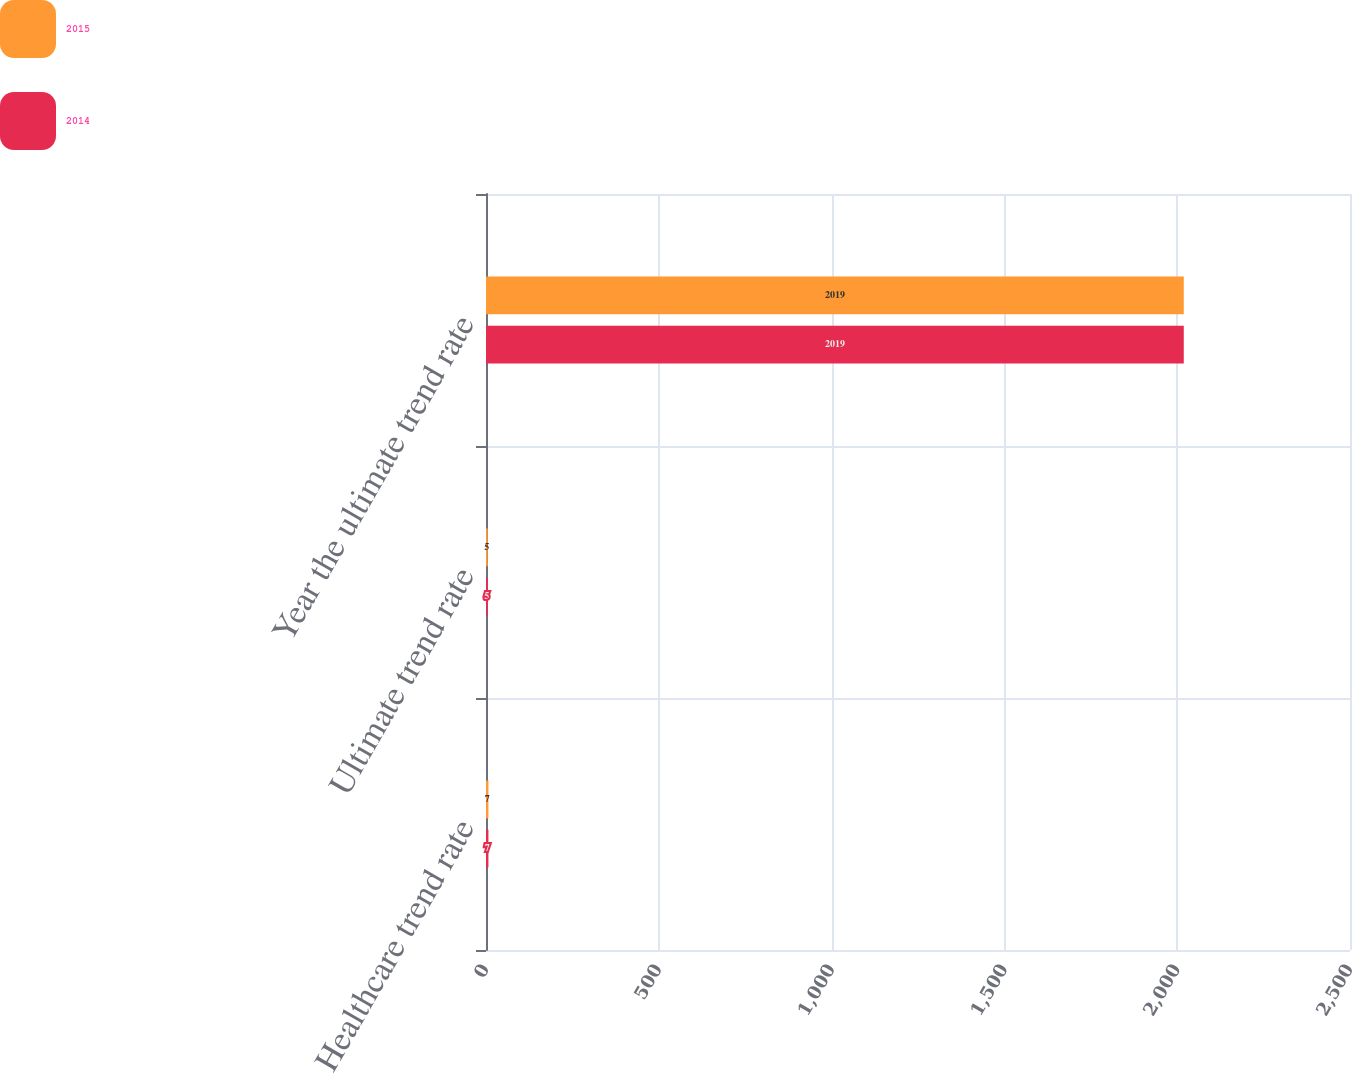Convert chart. <chart><loc_0><loc_0><loc_500><loc_500><stacked_bar_chart><ecel><fcel>Healthcare trend rate<fcel>Ultimate trend rate<fcel>Year the ultimate trend rate<nl><fcel>2015<fcel>7<fcel>5<fcel>2019<nl><fcel>2014<fcel>7<fcel>5<fcel>2019<nl></chart> 